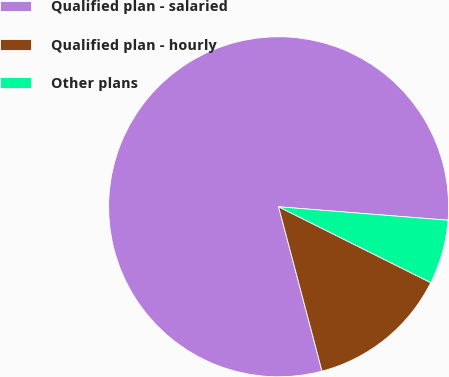<chart> <loc_0><loc_0><loc_500><loc_500><pie_chart><fcel>Qualified plan - salaried<fcel>Qualified plan - hourly<fcel>Other plans<nl><fcel>80.37%<fcel>13.53%<fcel>6.1%<nl></chart> 